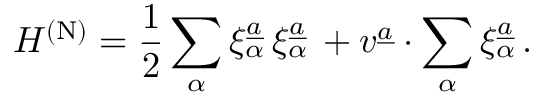<formula> <loc_0><loc_0><loc_500><loc_500>H ^ { ( N ) } = { \frac { 1 } { 2 } } \sum _ { \alpha } \xi _ { \alpha } ^ { \underline { a } } \, \xi _ { \alpha } ^ { \underline { a } } \, + v ^ { \underline { a } } \cdot \sum _ { \alpha } \xi _ { \alpha } ^ { \underline { a } } \, .</formula> 